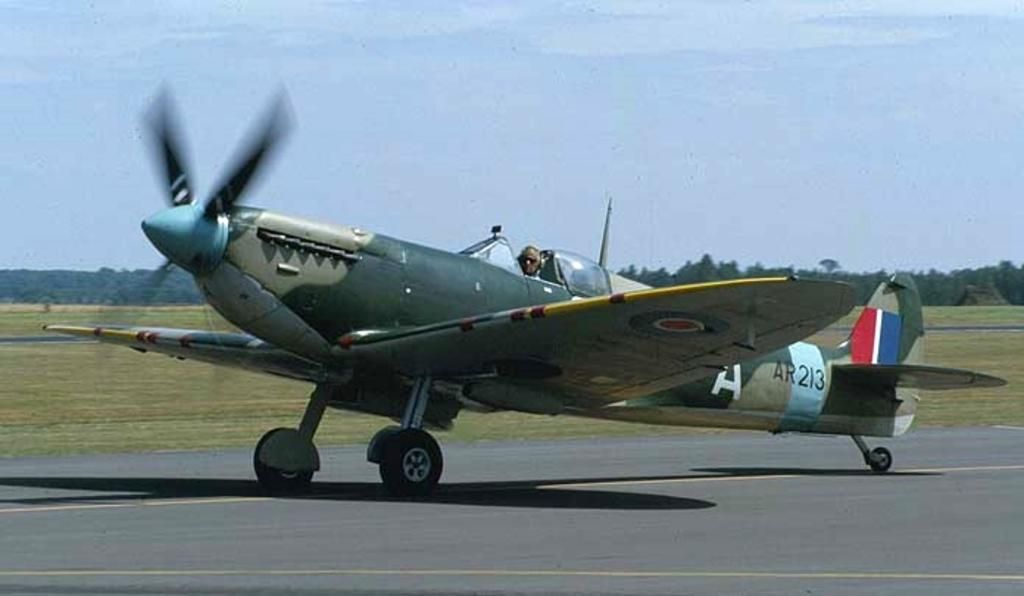<image>
Give a short and clear explanation of the subsequent image. An old style plane that has AR213 written on it. 